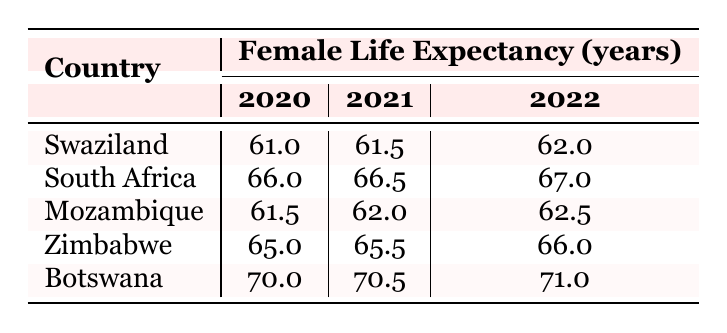What was the life expectancy of women in Swaziland in 2021? Referring to the table, the life expectancy of women in Swaziland for the year 2021 is provided in the corresponding cell under the column labeled 2021. That value is 61.5 years.
Answer: 61.5 Which country had the highest female life expectancy in 2022? In the table, we look at the values under the 2022 column. Botswana has the highest life expectancy for females at 71.0 years, compared to the other countries listed.
Answer: Botswana What is the average female life expectancy for the year 2020 among the listed countries? To find the average for 2020, we take the values: Swaziland (61.0), South Africa (66.0), Mozambique (61.5), Zimbabwe (65.0), and Botswana (70.0). The sum is 61.0 + 66.0 + 61.5 + 65.0 + 70.0 = 323. There are 5 data points, so 323/5 = 64.6.
Answer: 64.6 Did female life expectancy in Swaziland increase from 2020 to 2022? Looking at the values for Swaziland, in 2020 it was 61.0, and in 2022 it increased to 62.0. Since 62.0 is greater than 61.0, we conclude that there was an increase.
Answer: Yes What was the difference in female life expectancy between Zimbabwe and Mozambique in 2021? In 2021, female life expectancy was 65.5 years for Zimbabwe and 62.0 years for Mozambique. The difference is calculated by subtracting the value for Mozambique from that of Zimbabwe: 65.5 - 62.0 = 3.5.
Answer: 3.5 